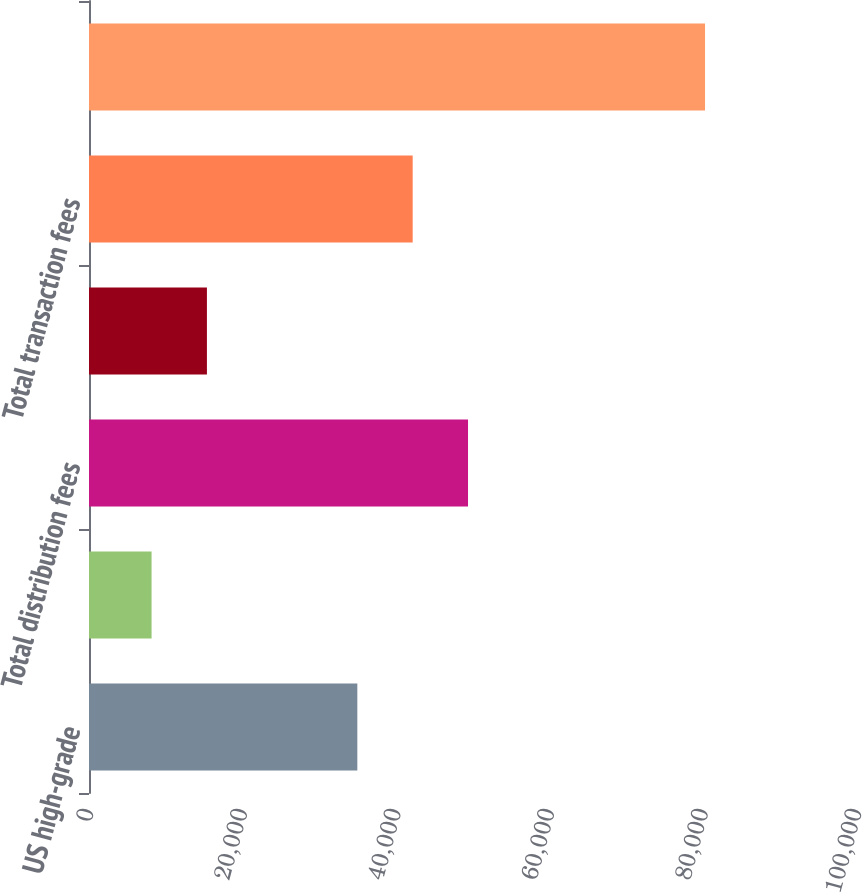Convert chart to OTSL. <chart><loc_0><loc_0><loc_500><loc_500><bar_chart><fcel>US high-grade<fcel>Eurobond<fcel>Total distribution fees<fcel>Other<fcel>Total transaction fees<fcel>Total commissions<nl><fcel>34939<fcel>8148<fcel>49352.2<fcel>15354.6<fcel>42145.6<fcel>80214<nl></chart> 